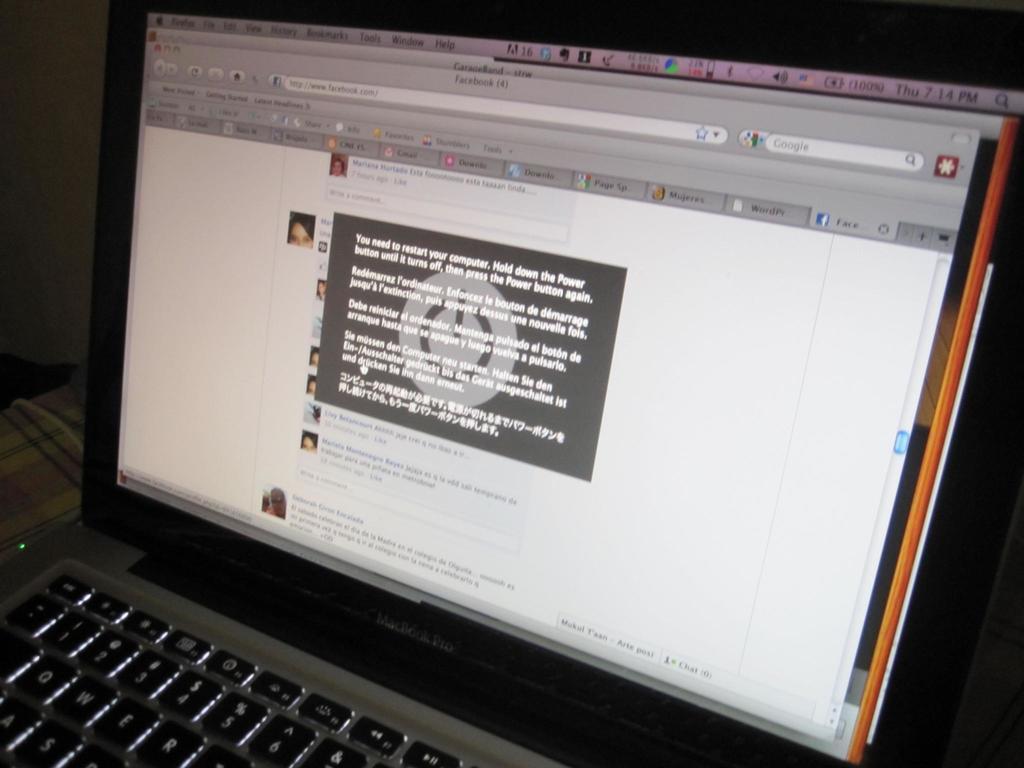Please provide a concise description of this image. In this image I can see a laptop. And on the laptop screen there are is a page with words. Also there is a dark background. 